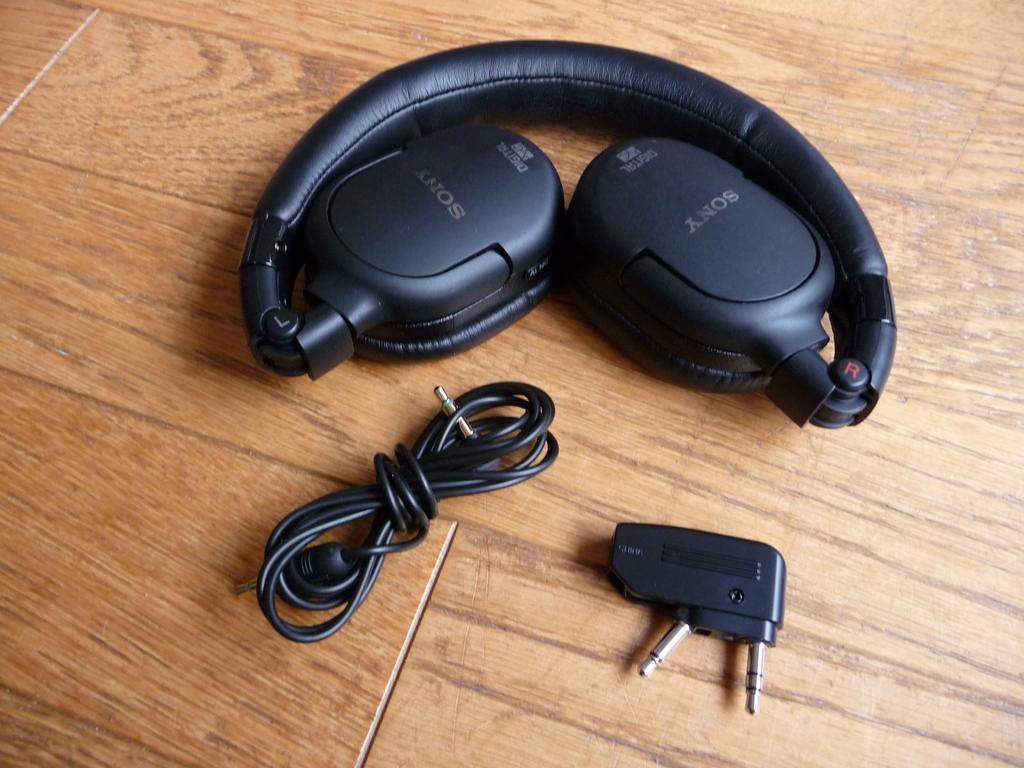Could you give a brief overview of what you see in this image? In this picture, we see a headset, cable and an adapter are placed on the brown table. 